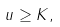<formula> <loc_0><loc_0><loc_500><loc_500>u \geq K ,</formula> 